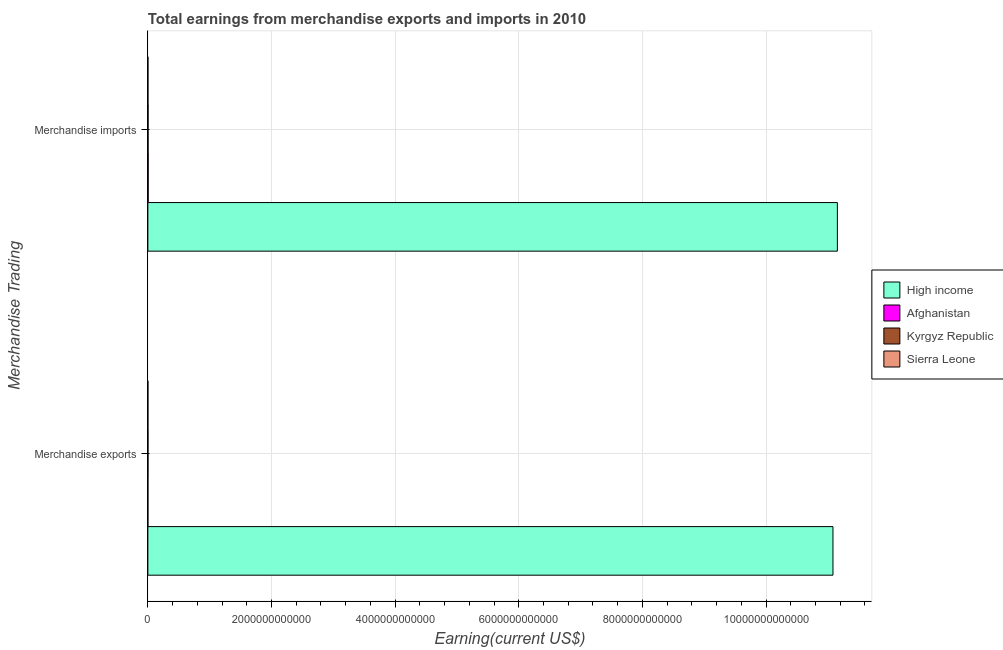How many different coloured bars are there?
Make the answer very short. 4. How many groups of bars are there?
Provide a short and direct response. 2. How many bars are there on the 2nd tick from the top?
Give a very brief answer. 4. What is the earnings from merchandise exports in High income?
Provide a short and direct response. 1.11e+13. Across all countries, what is the maximum earnings from merchandise imports?
Offer a terse response. 1.12e+13. Across all countries, what is the minimum earnings from merchandise imports?
Provide a succinct answer. 7.70e+08. In which country was the earnings from merchandise imports minimum?
Keep it short and to the point. Sierra Leone. What is the total earnings from merchandise exports in the graph?
Your answer should be compact. 1.11e+13. What is the difference between the earnings from merchandise imports in Afghanistan and that in Sierra Leone?
Provide a short and direct response. 4.38e+09. What is the difference between the earnings from merchandise exports in High income and the earnings from merchandise imports in Afghanistan?
Provide a short and direct response. 1.11e+13. What is the average earnings from merchandise imports per country?
Provide a short and direct response. 2.79e+12. What is the difference between the earnings from merchandise exports and earnings from merchandise imports in High income?
Provide a short and direct response. -7.13e+1. What is the ratio of the earnings from merchandise imports in Afghanistan to that in Kyrgyz Republic?
Your response must be concise. 1.6. Is the earnings from merchandise imports in Afghanistan less than that in Kyrgyz Republic?
Make the answer very short. No. What does the 4th bar from the top in Merchandise imports represents?
Keep it short and to the point. High income. What does the 2nd bar from the bottom in Merchandise imports represents?
Your answer should be compact. Afghanistan. How many countries are there in the graph?
Your answer should be compact. 4. What is the difference between two consecutive major ticks on the X-axis?
Your answer should be compact. 2.00e+12. Does the graph contain any zero values?
Offer a very short reply. No. Does the graph contain grids?
Provide a succinct answer. Yes. What is the title of the graph?
Offer a terse response. Total earnings from merchandise exports and imports in 2010. Does "Albania" appear as one of the legend labels in the graph?
Your response must be concise. No. What is the label or title of the X-axis?
Give a very brief answer. Earning(current US$). What is the label or title of the Y-axis?
Provide a succinct answer. Merchandise Trading. What is the Earning(current US$) in High income in Merchandise exports?
Ensure brevity in your answer.  1.11e+13. What is the Earning(current US$) in Afghanistan in Merchandise exports?
Your response must be concise. 3.88e+08. What is the Earning(current US$) of Kyrgyz Republic in Merchandise exports?
Offer a very short reply. 1.76e+09. What is the Earning(current US$) of Sierra Leone in Merchandise exports?
Give a very brief answer. 3.41e+08. What is the Earning(current US$) of High income in Merchandise imports?
Provide a succinct answer. 1.12e+13. What is the Earning(current US$) in Afghanistan in Merchandise imports?
Keep it short and to the point. 5.15e+09. What is the Earning(current US$) in Kyrgyz Republic in Merchandise imports?
Your answer should be very brief. 3.22e+09. What is the Earning(current US$) in Sierra Leone in Merchandise imports?
Your answer should be compact. 7.70e+08. Across all Merchandise Trading, what is the maximum Earning(current US$) in High income?
Offer a terse response. 1.12e+13. Across all Merchandise Trading, what is the maximum Earning(current US$) of Afghanistan?
Your answer should be very brief. 5.15e+09. Across all Merchandise Trading, what is the maximum Earning(current US$) in Kyrgyz Republic?
Keep it short and to the point. 3.22e+09. Across all Merchandise Trading, what is the maximum Earning(current US$) in Sierra Leone?
Your answer should be compact. 7.70e+08. Across all Merchandise Trading, what is the minimum Earning(current US$) in High income?
Provide a succinct answer. 1.11e+13. Across all Merchandise Trading, what is the minimum Earning(current US$) of Afghanistan?
Give a very brief answer. 3.88e+08. Across all Merchandise Trading, what is the minimum Earning(current US$) of Kyrgyz Republic?
Give a very brief answer. 1.76e+09. Across all Merchandise Trading, what is the minimum Earning(current US$) in Sierra Leone?
Ensure brevity in your answer.  3.41e+08. What is the total Earning(current US$) in High income in the graph?
Your response must be concise. 2.22e+13. What is the total Earning(current US$) in Afghanistan in the graph?
Your answer should be compact. 5.54e+09. What is the total Earning(current US$) in Kyrgyz Republic in the graph?
Give a very brief answer. 4.98e+09. What is the total Earning(current US$) of Sierra Leone in the graph?
Provide a succinct answer. 1.11e+09. What is the difference between the Earning(current US$) in High income in Merchandise exports and that in Merchandise imports?
Ensure brevity in your answer.  -7.13e+1. What is the difference between the Earning(current US$) of Afghanistan in Merchandise exports and that in Merchandise imports?
Provide a short and direct response. -4.77e+09. What is the difference between the Earning(current US$) of Kyrgyz Republic in Merchandise exports and that in Merchandise imports?
Provide a short and direct response. -1.47e+09. What is the difference between the Earning(current US$) in Sierra Leone in Merchandise exports and that in Merchandise imports?
Provide a short and direct response. -4.29e+08. What is the difference between the Earning(current US$) in High income in Merchandise exports and the Earning(current US$) in Afghanistan in Merchandise imports?
Offer a very short reply. 1.11e+13. What is the difference between the Earning(current US$) of High income in Merchandise exports and the Earning(current US$) of Kyrgyz Republic in Merchandise imports?
Keep it short and to the point. 1.11e+13. What is the difference between the Earning(current US$) in High income in Merchandise exports and the Earning(current US$) in Sierra Leone in Merchandise imports?
Offer a very short reply. 1.11e+13. What is the difference between the Earning(current US$) in Afghanistan in Merchandise exports and the Earning(current US$) in Kyrgyz Republic in Merchandise imports?
Keep it short and to the point. -2.83e+09. What is the difference between the Earning(current US$) of Afghanistan in Merchandise exports and the Earning(current US$) of Sierra Leone in Merchandise imports?
Give a very brief answer. -3.82e+08. What is the difference between the Earning(current US$) of Kyrgyz Republic in Merchandise exports and the Earning(current US$) of Sierra Leone in Merchandise imports?
Your answer should be compact. 9.86e+08. What is the average Earning(current US$) in High income per Merchandise Trading?
Offer a very short reply. 1.11e+13. What is the average Earning(current US$) in Afghanistan per Merchandise Trading?
Offer a very short reply. 2.77e+09. What is the average Earning(current US$) of Kyrgyz Republic per Merchandise Trading?
Your response must be concise. 2.49e+09. What is the average Earning(current US$) in Sierra Leone per Merchandise Trading?
Ensure brevity in your answer.  5.56e+08. What is the difference between the Earning(current US$) in High income and Earning(current US$) in Afghanistan in Merchandise exports?
Make the answer very short. 1.11e+13. What is the difference between the Earning(current US$) in High income and Earning(current US$) in Kyrgyz Republic in Merchandise exports?
Ensure brevity in your answer.  1.11e+13. What is the difference between the Earning(current US$) of High income and Earning(current US$) of Sierra Leone in Merchandise exports?
Offer a very short reply. 1.11e+13. What is the difference between the Earning(current US$) of Afghanistan and Earning(current US$) of Kyrgyz Republic in Merchandise exports?
Ensure brevity in your answer.  -1.37e+09. What is the difference between the Earning(current US$) of Afghanistan and Earning(current US$) of Sierra Leone in Merchandise exports?
Keep it short and to the point. 4.73e+07. What is the difference between the Earning(current US$) in Kyrgyz Republic and Earning(current US$) in Sierra Leone in Merchandise exports?
Ensure brevity in your answer.  1.41e+09. What is the difference between the Earning(current US$) of High income and Earning(current US$) of Afghanistan in Merchandise imports?
Your response must be concise. 1.11e+13. What is the difference between the Earning(current US$) of High income and Earning(current US$) of Kyrgyz Republic in Merchandise imports?
Ensure brevity in your answer.  1.12e+13. What is the difference between the Earning(current US$) of High income and Earning(current US$) of Sierra Leone in Merchandise imports?
Your answer should be compact. 1.12e+13. What is the difference between the Earning(current US$) of Afghanistan and Earning(current US$) of Kyrgyz Republic in Merchandise imports?
Ensure brevity in your answer.  1.93e+09. What is the difference between the Earning(current US$) in Afghanistan and Earning(current US$) in Sierra Leone in Merchandise imports?
Your answer should be compact. 4.38e+09. What is the difference between the Earning(current US$) of Kyrgyz Republic and Earning(current US$) of Sierra Leone in Merchandise imports?
Provide a succinct answer. 2.45e+09. What is the ratio of the Earning(current US$) of High income in Merchandise exports to that in Merchandise imports?
Keep it short and to the point. 0.99. What is the ratio of the Earning(current US$) in Afghanistan in Merchandise exports to that in Merchandise imports?
Your answer should be compact. 0.08. What is the ratio of the Earning(current US$) of Kyrgyz Republic in Merchandise exports to that in Merchandise imports?
Your answer should be compact. 0.54. What is the ratio of the Earning(current US$) of Sierra Leone in Merchandise exports to that in Merchandise imports?
Provide a short and direct response. 0.44. What is the difference between the highest and the second highest Earning(current US$) in High income?
Give a very brief answer. 7.13e+1. What is the difference between the highest and the second highest Earning(current US$) in Afghanistan?
Give a very brief answer. 4.77e+09. What is the difference between the highest and the second highest Earning(current US$) in Kyrgyz Republic?
Provide a short and direct response. 1.47e+09. What is the difference between the highest and the second highest Earning(current US$) in Sierra Leone?
Offer a terse response. 4.29e+08. What is the difference between the highest and the lowest Earning(current US$) of High income?
Make the answer very short. 7.13e+1. What is the difference between the highest and the lowest Earning(current US$) in Afghanistan?
Your response must be concise. 4.77e+09. What is the difference between the highest and the lowest Earning(current US$) of Kyrgyz Republic?
Keep it short and to the point. 1.47e+09. What is the difference between the highest and the lowest Earning(current US$) in Sierra Leone?
Offer a terse response. 4.29e+08. 